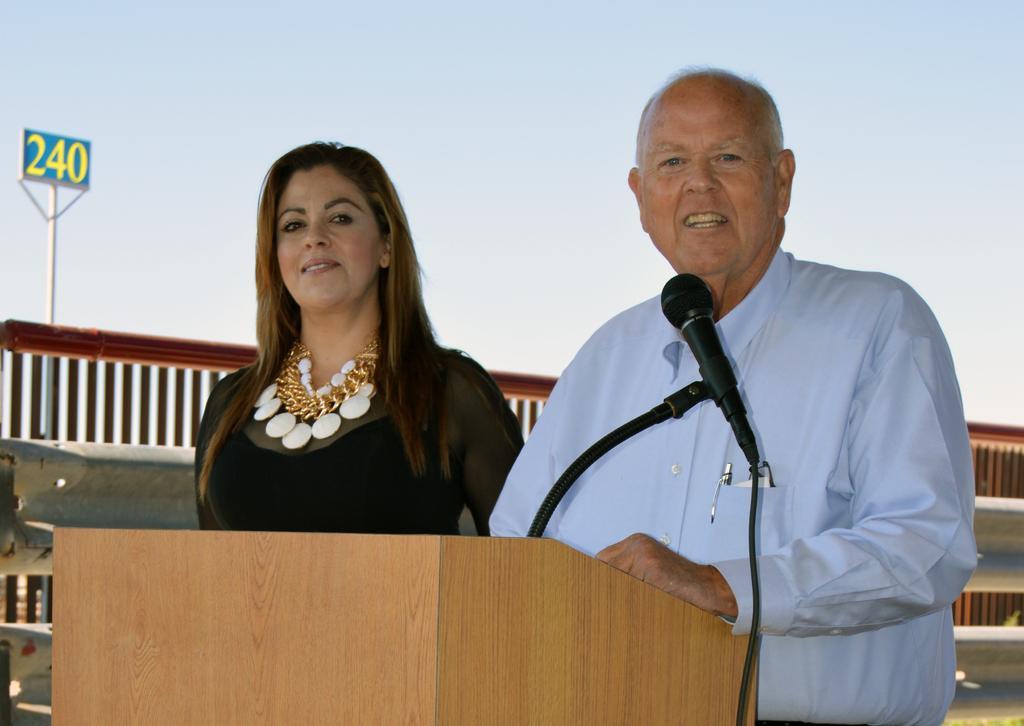How would you summarize this image in a sentence or two? In this picture we can see a man and a woman smiling and in front of them we can see a mic on the podium and at the back of them we can see a pole, number board and some objects and in the background we can see the sky. 